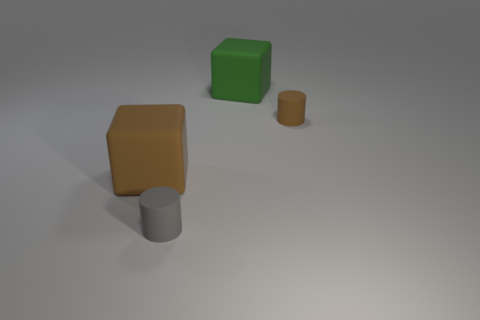Is there anything else that has the same material as the big green cube?
Offer a very short reply. Yes. There is a thing that is both on the right side of the gray matte cylinder and in front of the green matte thing; what material is it?
Ensure brevity in your answer.  Rubber. How many large yellow metal things have the same shape as the gray object?
Offer a very short reply. 0. There is a large object that is on the right side of the matte thing that is in front of the large brown matte cube; what color is it?
Your answer should be compact. Green. Are there the same number of rubber cylinders in front of the gray thing and brown matte cylinders?
Your answer should be compact. No. Are there any gray matte cylinders of the same size as the brown matte cylinder?
Your response must be concise. Yes. Do the brown matte block and the cube that is behind the small brown rubber thing have the same size?
Your answer should be compact. Yes. Are there an equal number of large rubber blocks that are in front of the big green rubber thing and large brown rubber objects to the right of the tiny brown cylinder?
Offer a terse response. No. What is the material of the cylinder that is in front of the big brown rubber block?
Keep it short and to the point. Rubber. Do the gray cylinder and the brown cylinder have the same size?
Ensure brevity in your answer.  Yes. 